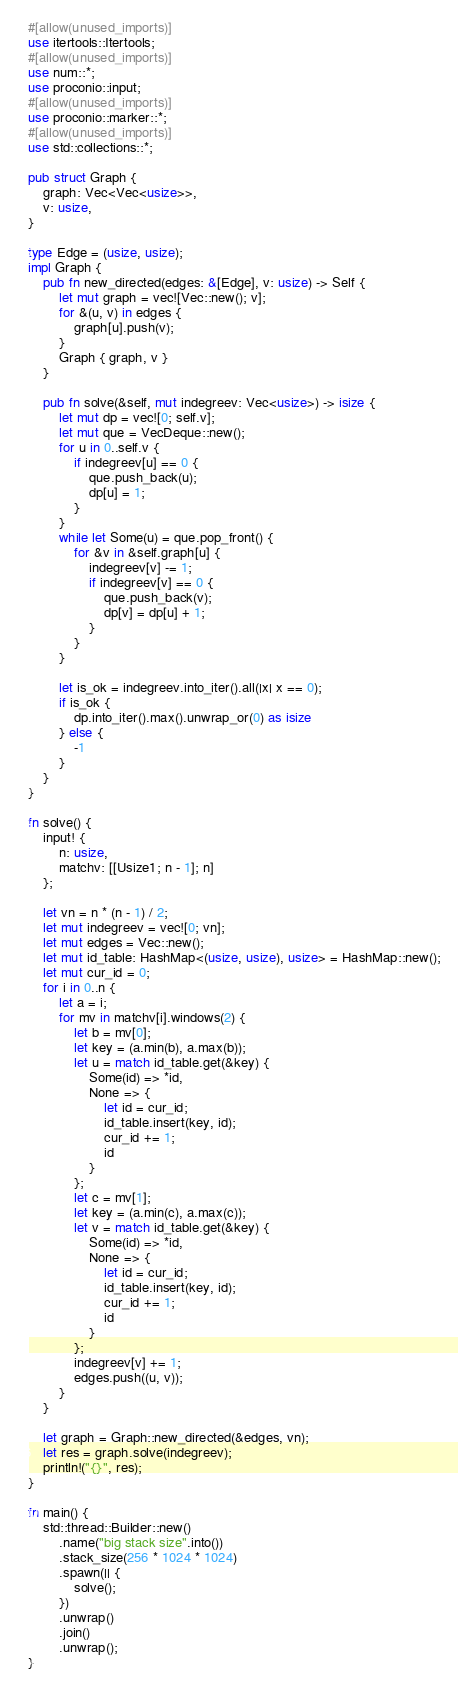<code> <loc_0><loc_0><loc_500><loc_500><_Rust_>#[allow(unused_imports)]
use itertools::Itertools;
#[allow(unused_imports)]
use num::*;
use proconio::input;
#[allow(unused_imports)]
use proconio::marker::*;
#[allow(unused_imports)]
use std::collections::*;

pub struct Graph {
    graph: Vec<Vec<usize>>,
    v: usize,
}

type Edge = (usize, usize);
impl Graph {
    pub fn new_directed(edges: &[Edge], v: usize) -> Self {
        let mut graph = vec![Vec::new(); v];
        for &(u, v) in edges {
            graph[u].push(v);
        }
        Graph { graph, v }
    }

    pub fn solve(&self, mut indegreev: Vec<usize>) -> isize {
        let mut dp = vec![0; self.v];
        let mut que = VecDeque::new();
        for u in 0..self.v {
            if indegreev[u] == 0 {
                que.push_back(u);
                dp[u] = 1;
            }
        }
        while let Some(u) = que.pop_front() {
            for &v in &self.graph[u] {
                indegreev[v] -= 1;
                if indegreev[v] == 0 {
                    que.push_back(v);
                    dp[v] = dp[u] + 1;
                }
            }
        }

        let is_ok = indegreev.into_iter().all(|x| x == 0);
        if is_ok {
            dp.into_iter().max().unwrap_or(0) as isize
        } else {
            -1
        }
    }
}

fn solve() {
    input! {
        n: usize,
        matchv: [[Usize1; n - 1]; n]
    };

    let vn = n * (n - 1) / 2;
    let mut indegreev = vec![0; vn];
    let mut edges = Vec::new();
    let mut id_table: HashMap<(usize, usize), usize> = HashMap::new();
    let mut cur_id = 0;
    for i in 0..n {
        let a = i;
        for mv in matchv[i].windows(2) {
            let b = mv[0];
            let key = (a.min(b), a.max(b));
            let u = match id_table.get(&key) {
                Some(id) => *id,
                None => {
                    let id = cur_id;
                    id_table.insert(key, id);
                    cur_id += 1;
                    id
                }
            };
            let c = mv[1];
            let key = (a.min(c), a.max(c));
            let v = match id_table.get(&key) {
                Some(id) => *id,
                None => {
                    let id = cur_id;
                    id_table.insert(key, id);
                    cur_id += 1;
                    id
                }
            };
            indegreev[v] += 1;
            edges.push((u, v));
        }
    }

    let graph = Graph::new_directed(&edges, vn);
    let res = graph.solve(indegreev);
    println!("{}", res);
}

fn main() {
    std::thread::Builder::new()
        .name("big stack size".into())
        .stack_size(256 * 1024 * 1024)
        .spawn(|| {
            solve();
        })
        .unwrap()
        .join()
        .unwrap();
}
</code> 